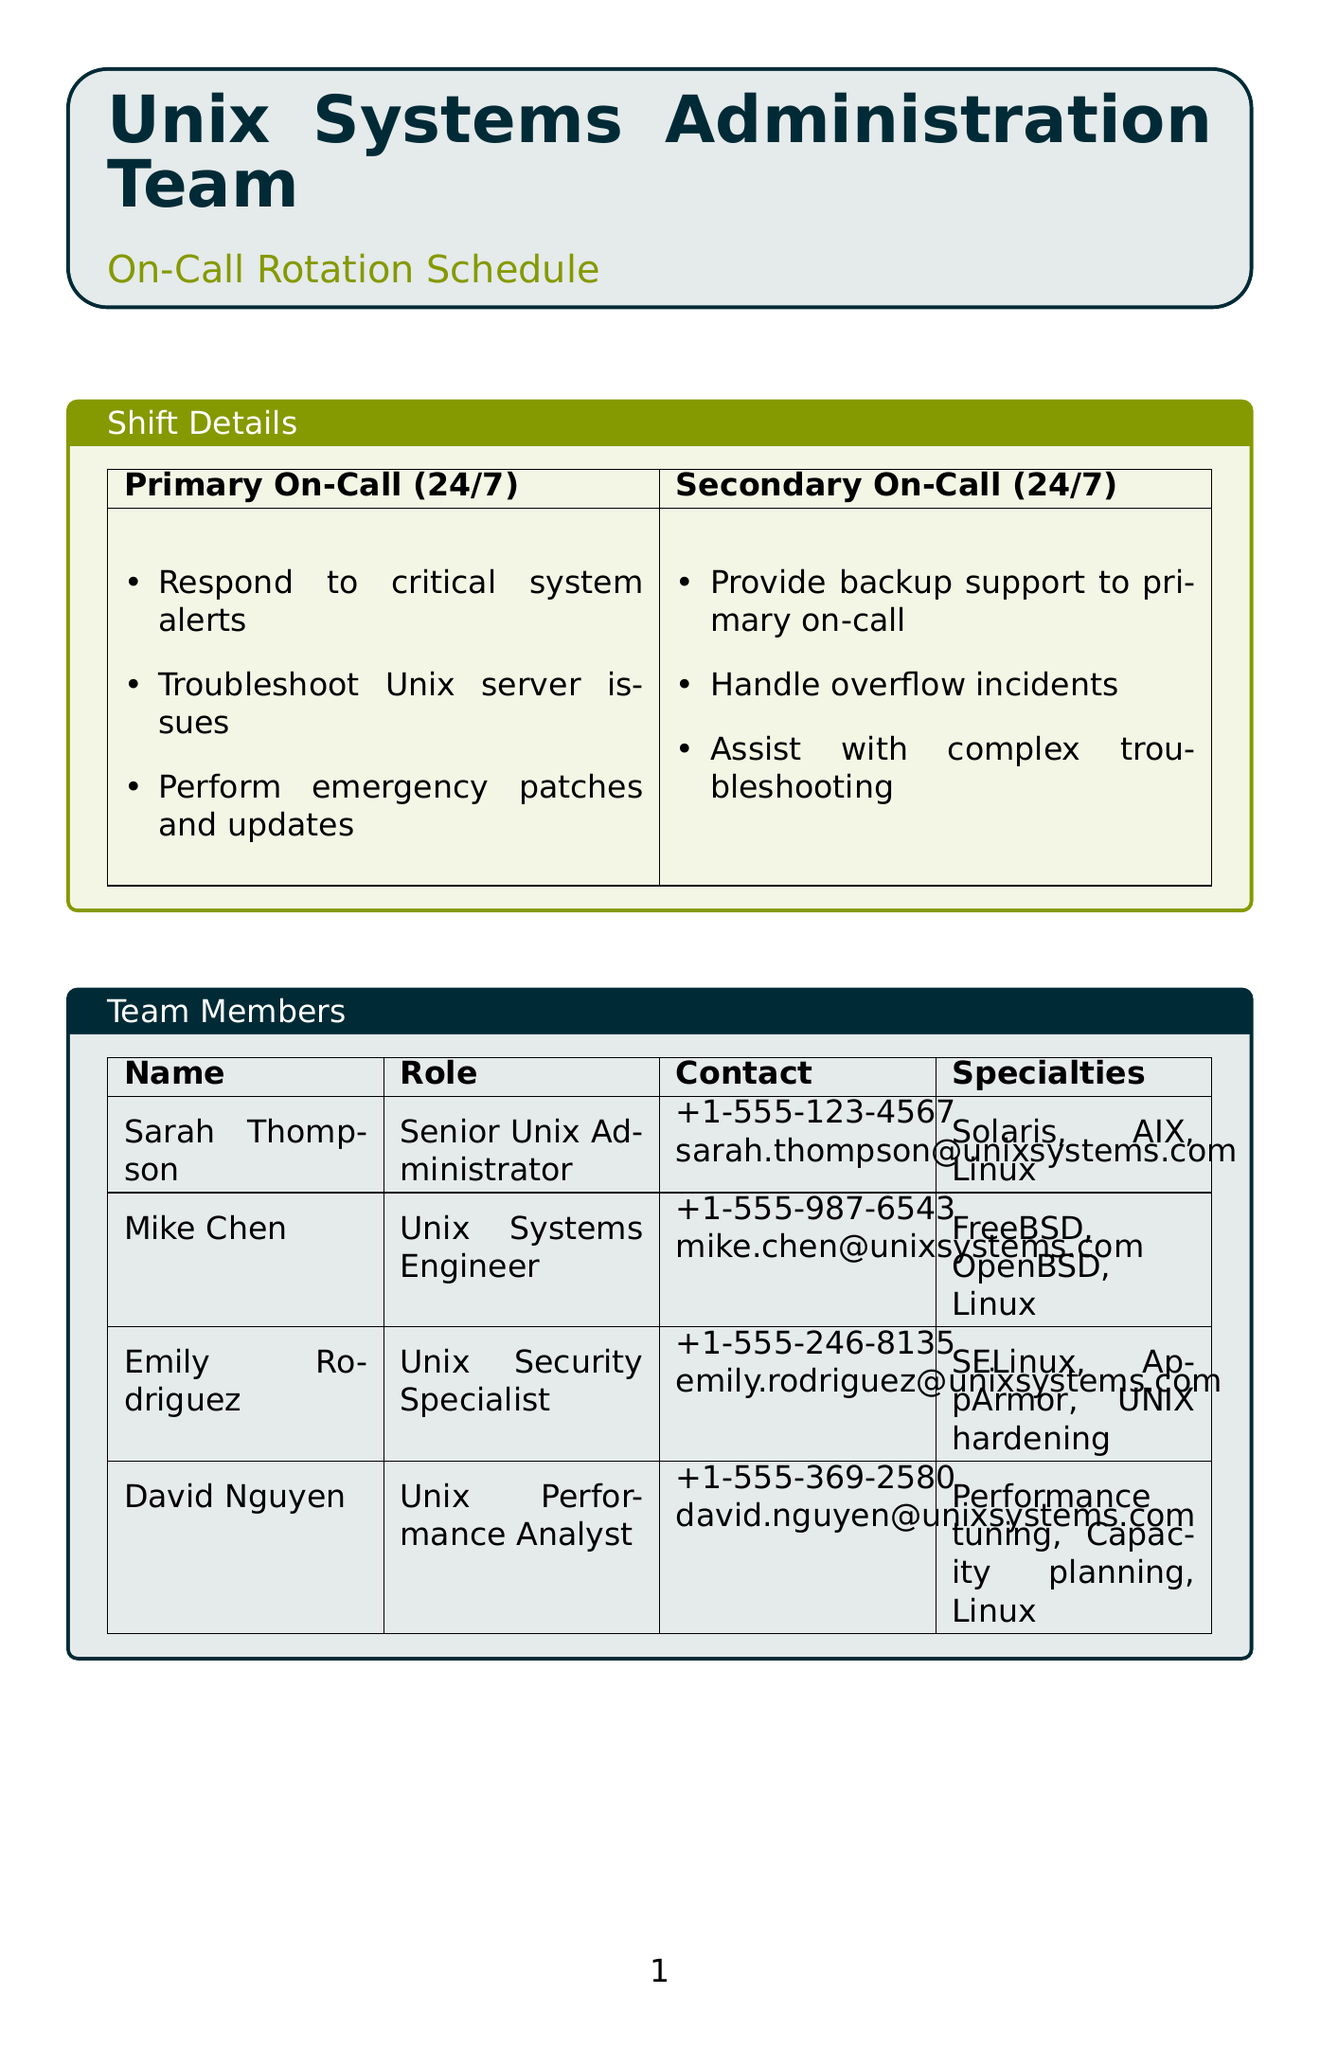what is the name of the primary on-call contact? The primary on-call contact is the first person listed in the team members section, which is Sarah Thompson.
Answer: Sarah Thompson how long is the rotation period for the Unix team? The rotation period is specified directly in the document as being weekly.
Answer: Weekly what is the contact number for Mike Chen? The contact number for Mike Chen is recorded in the team members section.
Answer: +1-555-987-6543 who provides backup support to the primary on-call? The document specifies that the secondary on-call role provides backup support to the primary on-call.
Answer: Secondary On-Call how long is the primary on-call shift? The duration for the primary on-call shift is included in the shift details section, which states it is ongoing.
Answer: 24/7 which tool is used for system monitoring and alerting? The purpose of the listed tools includes their specific functionalities; Nagios is mentioned for monitoring and alerting.
Answer: Nagios what should you do if there is no response from the primary on-call within 15 minutes? The escalation procedure states that you should contact the secondary on-call if there is no response from the primary within the specified time.
Answer: Contact secondary on-call where can the Unix Team Runbook be found? The location of the Unix Team Runbook is included in the reference documents section, specifying its directory path.
Answer: /shared/docs/unix_runbook.pdf what is the purpose of the Slack channel? The document details the purpose of Slack, specifically indicating it is for team communication and updates.
Answer: Team communication and updates 